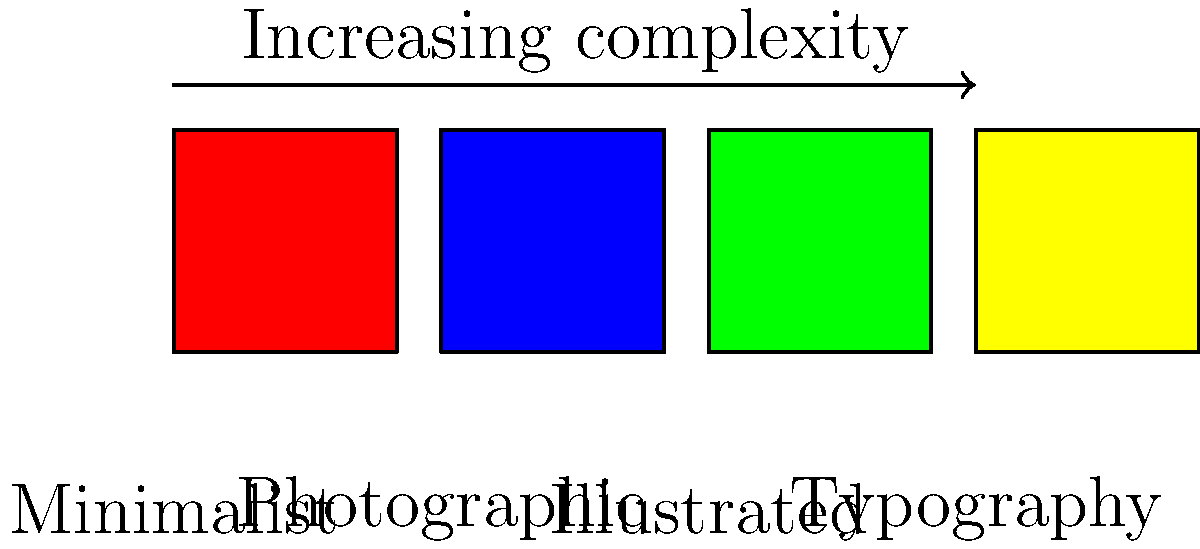In the context of classifying K-pop album cover art styles using image recognition, which style would likely require the most complex features for accurate classification, and why? To answer this question, let's analyze the complexity of features required for each style:

1. Minimalist: Often uses simple shapes, solid colors, and minimal elements. Features are straightforward, such as color distribution and basic geometric shapes.

2. Photographic: Requires more complex features like facial recognition, pose estimation, and scene analysis. However, these are well-established in image recognition.

3. Illustrated: Involves a wide range of artistic styles, from simple cartoons to complex digital art. Features may include brush stroke analysis, color palettes, and object recognition within illustrations.

4. Typography: Focuses on text elements, which can vary greatly in style, size, and arrangement. Features would need to include:
   a) Optical Character Recognition (OCR) to identify and read text
   b) Font style classification
   c) Text layout analysis
   d) Integration of text with other design elements

The Typography style is likely to require the most complex features because:
1. It combines elements of text recognition with overall design analysis.
2. Text can be highly stylized in K-pop album covers, making standard OCR challenging.
3. The arrangement and integration of text with other design elements add another layer of complexity.
4. Typography-focused covers may still incorporate elements from other styles, requiring a broader range of feature detection.

This combination of text and design analysis makes Typography the most challenging for image recognition systems to accurately classify.
Answer: Typography 